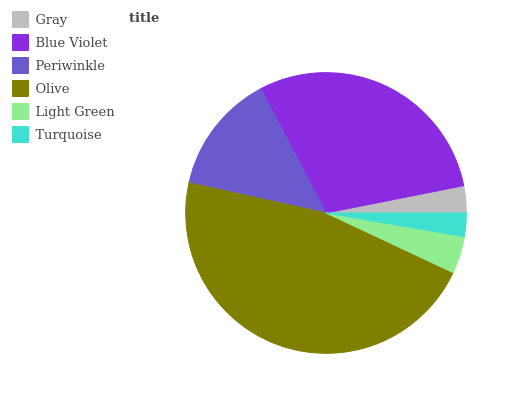Is Turquoise the minimum?
Answer yes or no. Yes. Is Olive the maximum?
Answer yes or no. Yes. Is Blue Violet the minimum?
Answer yes or no. No. Is Blue Violet the maximum?
Answer yes or no. No. Is Blue Violet greater than Gray?
Answer yes or no. Yes. Is Gray less than Blue Violet?
Answer yes or no. Yes. Is Gray greater than Blue Violet?
Answer yes or no. No. Is Blue Violet less than Gray?
Answer yes or no. No. Is Periwinkle the high median?
Answer yes or no. Yes. Is Light Green the low median?
Answer yes or no. Yes. Is Light Green the high median?
Answer yes or no. No. Is Olive the low median?
Answer yes or no. No. 